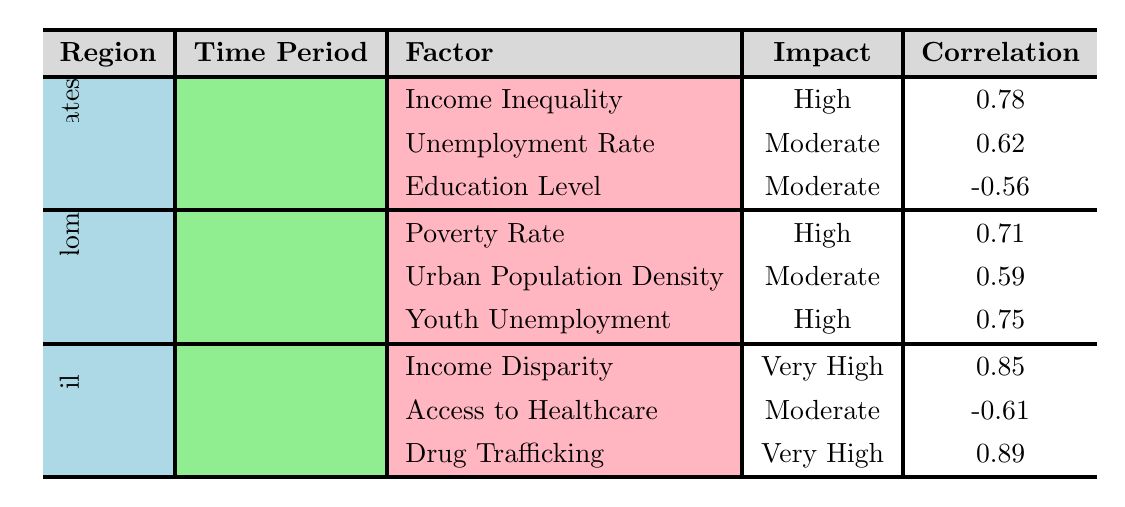What is the Gini Coefficient correlation in the United States? The correlation for the Gini Coefficient in the United States is listed in the table as 0.78.
Answer: 0.78 Which socioeconomic factor has a "Very High" impact on violent crime rates in Brazil? In Brazil, both Income Disparity and Drug Trafficking are indicated as having a "Very High" impact on violent crime rates.
Answer: Income Disparity and Drug Trafficking What is the correlation for Youth Unemployment in the United Kingdom? The correlation for Youth Unemployment in the United Kingdom is shown in the table as 0.75.
Answer: 0.75 Is the Unemployment Rate in the United States listed as having a high impact on violent crime rates? The table shows that the Unemployment Rate has a "Moderate" impact on violent crime rates, not a "High" impact.
Answer: No Which region had the highest correlation with socioeconomic factors contributing to violent crime? Comparing the highest correlations in each region: United States has 0.78, United Kingdom has 0.75, and Brazil has 0.89. Brazil has the highest correlation.
Answer: Brazil What is the average correlation of the factors listed for the United Kingdom? To find the average, sum the correlations for the United Kingdom: (0.71 + 0.59 + 0.75) = 2.05. There are 3 factors, so the average is 2.05 / 3 = 0.683.
Answer: 0.683 Which region shows a negative correlation for any factor? The United States shows a negative correlation for Education Level, listed as -0.56.
Answer: United States Does the table indicate that drug trafficking has a higher impact than income disparity in Brazil? Both drug trafficking and income disparity are rated as having a "Very High" impact, so their impacts are equal but not directly comparable in terms of higher or lower.
Answer: No What percentage of the 15-24 age group is classified as youth unemployment in the United Kingdom? The table specifies that youth unemployment is classified as a percentage, represented without a specific value in the data; it is not a direct percentage provided.
Answer: Not specified Which socioeconomic factor in the United States has the highest correlation to violent crime rates? Among the factors listed for the United States, the Gini Coefficient has the highest correlation at 0.78.
Answer: Income Inequality How does the correlation of Access to Healthcare affect violent crime rates in Brazil? The correlation for Access to Healthcare is -0.61, indicating a negative relationship. This means as access improves, violent crime rates may decrease, according to the data.
Answer: Negative correlation 